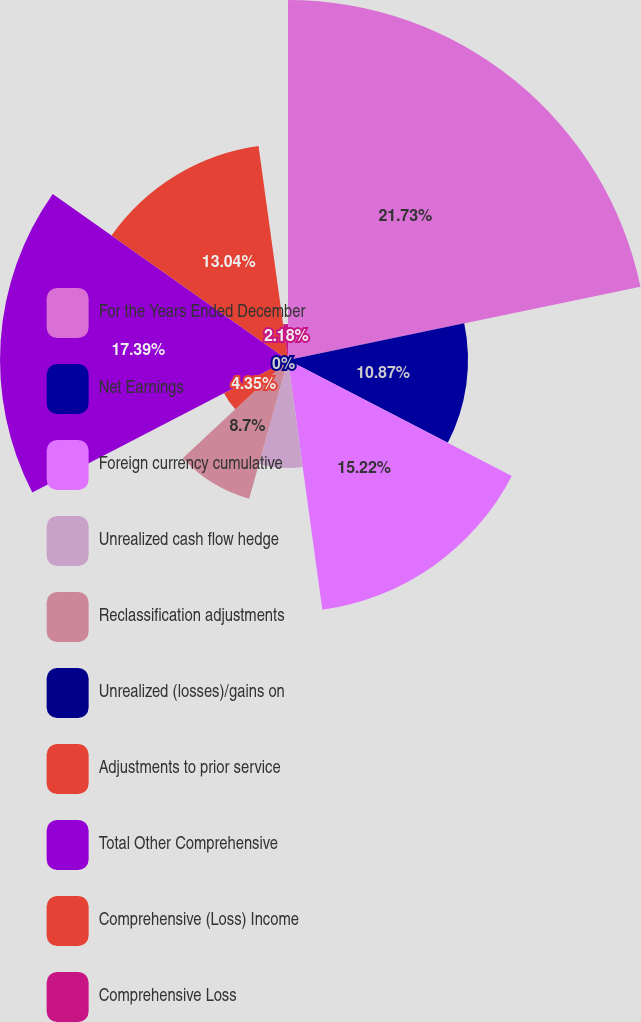<chart> <loc_0><loc_0><loc_500><loc_500><pie_chart><fcel>For the Years Ended December<fcel>Net Earnings<fcel>Foreign currency cumulative<fcel>Unrealized cash flow hedge<fcel>Reclassification adjustments<fcel>Unrealized (losses)/gains on<fcel>Adjustments to prior service<fcel>Total Other Comprehensive<fcel>Comprehensive (Loss) Income<fcel>Comprehensive Loss<nl><fcel>21.74%<fcel>10.87%<fcel>15.22%<fcel>6.52%<fcel>8.7%<fcel>0.0%<fcel>4.35%<fcel>17.39%<fcel>13.04%<fcel>2.18%<nl></chart> 